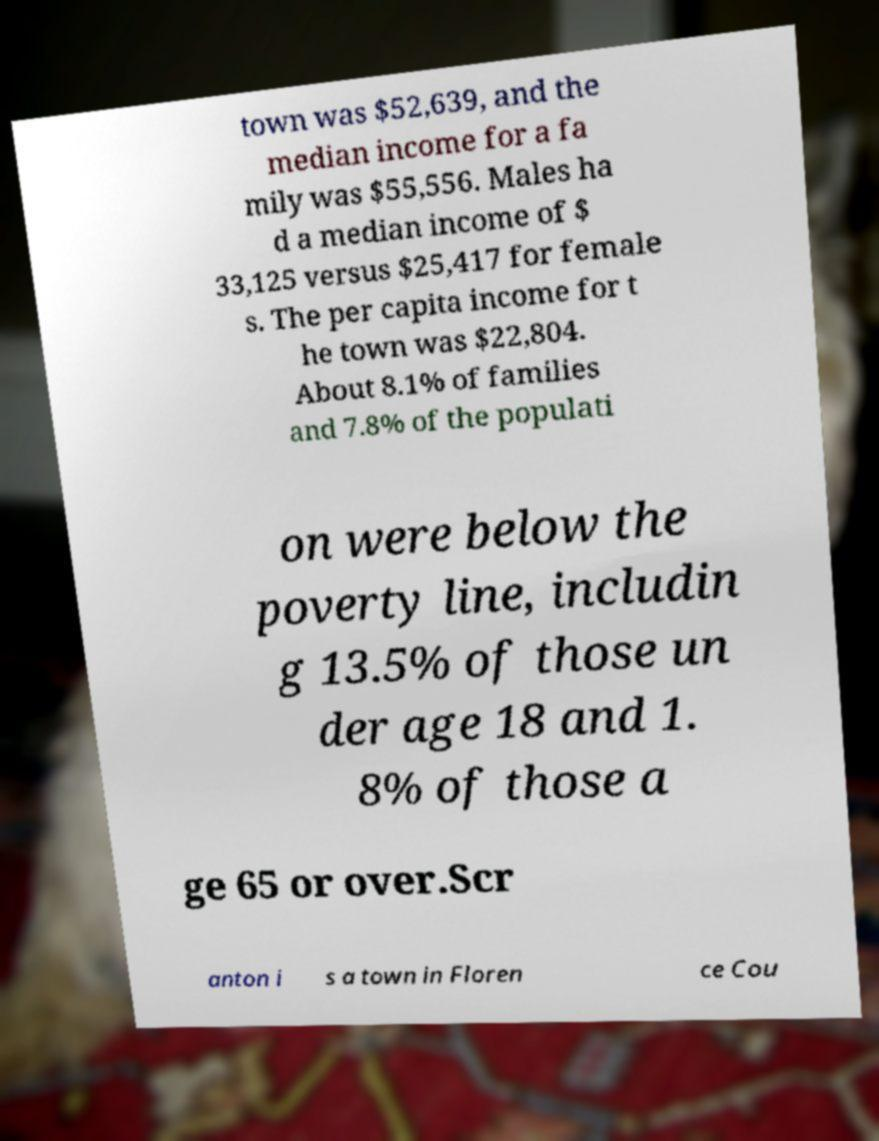Could you assist in decoding the text presented in this image and type it out clearly? town was $52,639, and the median income for a fa mily was $55,556. Males ha d a median income of $ 33,125 versus $25,417 for female s. The per capita income for t he town was $22,804. About 8.1% of families and 7.8% of the populati on were below the poverty line, includin g 13.5% of those un der age 18 and 1. 8% of those a ge 65 or over.Scr anton i s a town in Floren ce Cou 